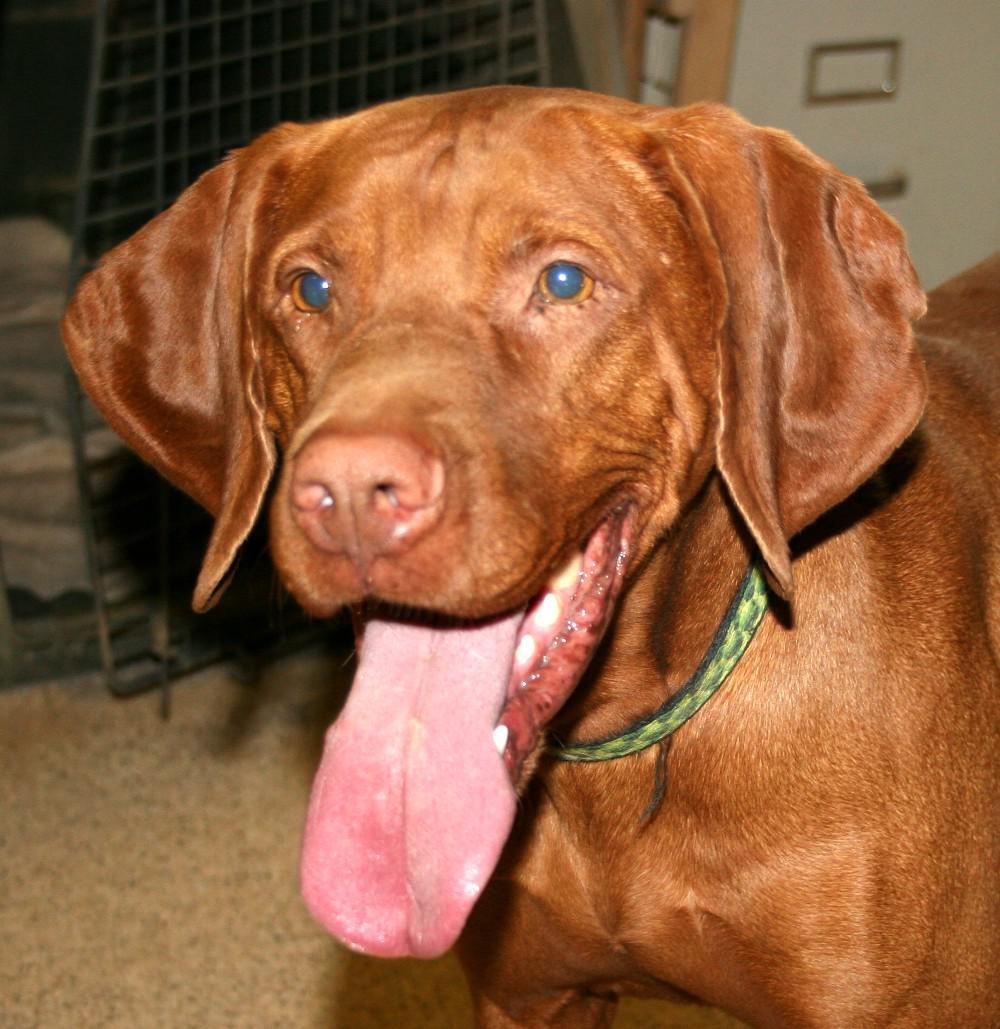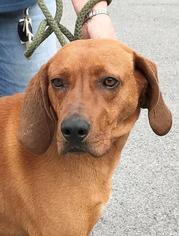The first image is the image on the left, the second image is the image on the right. For the images shown, is this caption "One image features a dog in a collar with his head angled to the left and his tongue hanging down." true? Answer yes or no. Yes. The first image is the image on the left, the second image is the image on the right. Analyze the images presented: Is the assertion "The dogs in both of the images are outside." valid? Answer yes or no. No. 